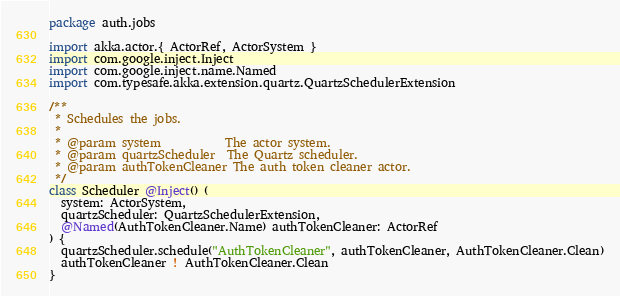<code> <loc_0><loc_0><loc_500><loc_500><_Scala_>package auth.jobs

import akka.actor.{ ActorRef, ActorSystem }
import com.google.inject.Inject
import com.google.inject.name.Named
import com.typesafe.akka.extension.quartz.QuartzSchedulerExtension

/**
 * Schedules the jobs.
 *
 * @param system           The actor system.
 * @param quartzScheduler  The Quartz scheduler.
 * @param authTokenCleaner The auth token cleaner actor.
 */
class Scheduler @Inject() (
  system: ActorSystem,
  quartzScheduler: QuartzSchedulerExtension,
  @Named(AuthTokenCleaner.Name) authTokenCleaner: ActorRef
) {
  quartzScheduler.schedule("AuthTokenCleaner", authTokenCleaner, AuthTokenCleaner.Clean)
  authTokenCleaner ! AuthTokenCleaner.Clean
}
</code> 